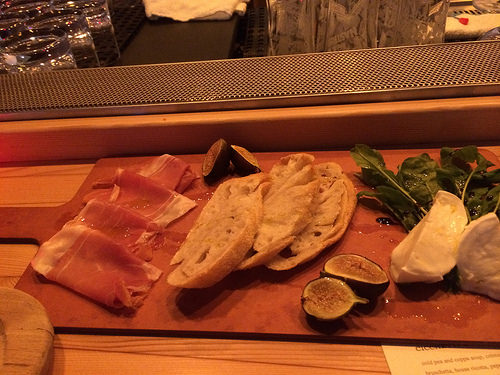<image>
Is there a bread on the chopping board? Yes. Looking at the image, I can see the bread is positioned on top of the chopping board, with the chopping board providing support. Where is the meat in relation to the fig? Is it next to the fig? Yes. The meat is positioned adjacent to the fig, located nearby in the same general area. 